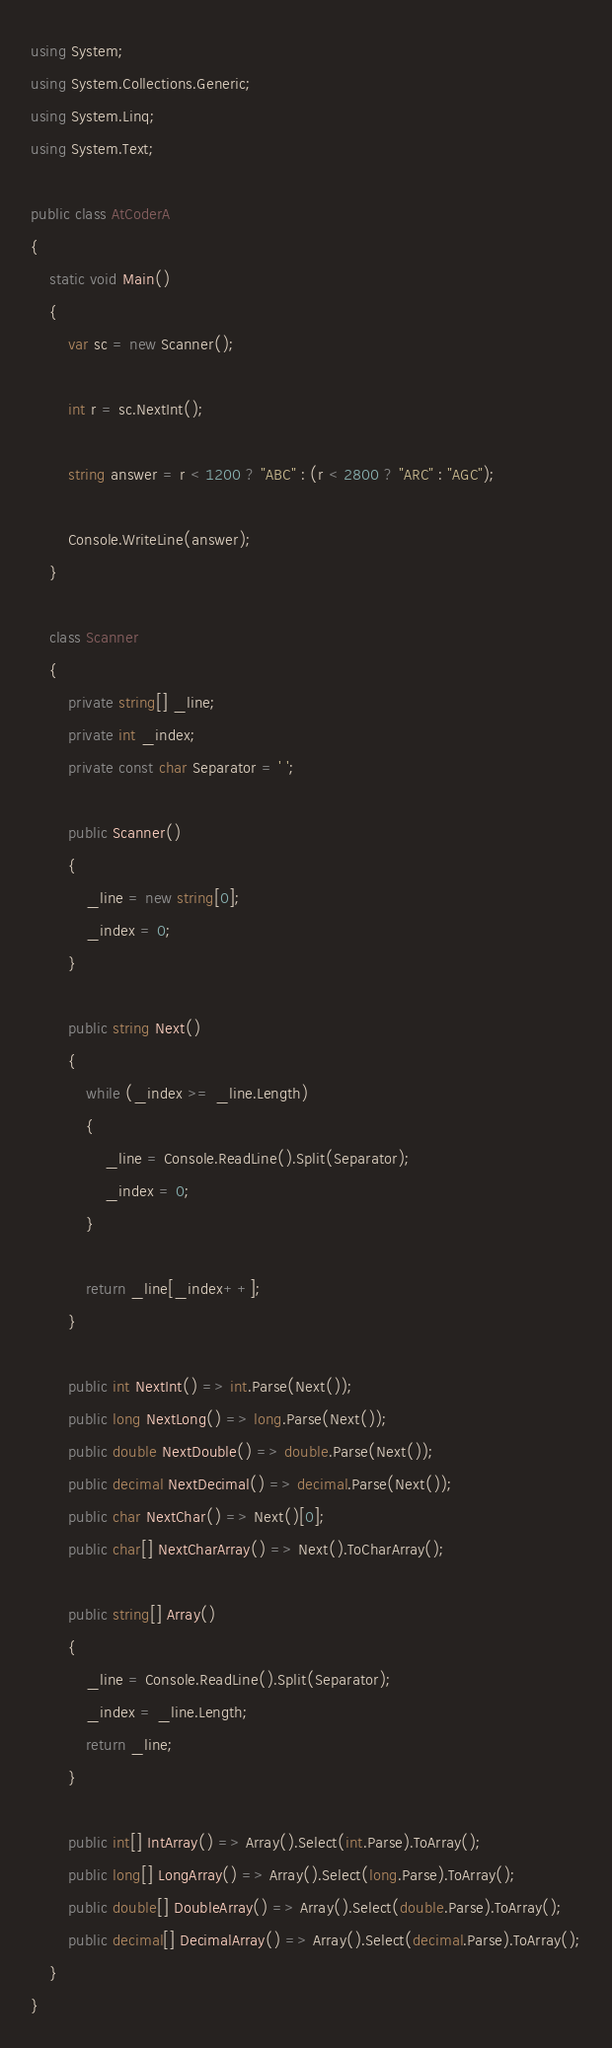<code> <loc_0><loc_0><loc_500><loc_500><_C#_>using System;
using System.Collections.Generic;
using System.Linq;
using System.Text;

public class AtCoderA
{
    static void Main()
    {
        var sc = new Scanner();

        int r = sc.NextInt();

        string answer = r < 1200 ? "ABC" : (r < 2800 ? "ARC" : "AGC");

        Console.WriteLine(answer);
    }

    class Scanner
    {
        private string[] _line;
        private int _index;
        private const char Separator = ' ';

        public Scanner()
        {
            _line = new string[0];
            _index = 0;
        }

        public string Next()
        {
            while (_index >= _line.Length)
            {
                _line = Console.ReadLine().Split(Separator);
                _index = 0;
            }

            return _line[_index++];
        }

        public int NextInt() => int.Parse(Next());
        public long NextLong() => long.Parse(Next());
        public double NextDouble() => double.Parse(Next());
        public decimal NextDecimal() => decimal.Parse(Next());
        public char NextChar() => Next()[0];
        public char[] NextCharArray() => Next().ToCharArray();

        public string[] Array()
        {
            _line = Console.ReadLine().Split(Separator);
            _index = _line.Length;
            return _line;
        }

        public int[] IntArray() => Array().Select(int.Parse).ToArray();
        public long[] LongArray() => Array().Select(long.Parse).ToArray();
        public double[] DoubleArray() => Array().Select(double.Parse).ToArray();
        public decimal[] DecimalArray() => Array().Select(decimal.Parse).ToArray();
    }
}</code> 